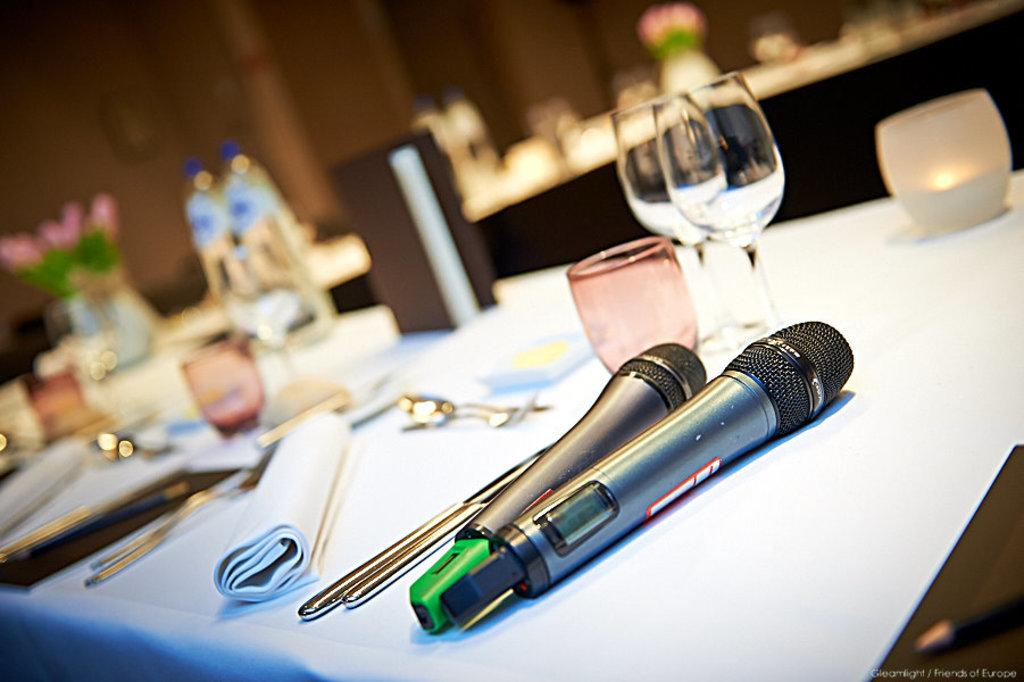What is located in the foreground of the image? In the foreground of the image, there are mice, glasses, spoons, tissue, and a candle. What objects can be seen in the same area as the mice? The glasses, spoons, tissue, and candle are all located in the same area as the mice in the foreground of the image. Can you describe the background of the image? The background of the image is blurred. What language is spoken by the mice in the image? There is no indication in the image that the mice are speaking any language. Is there a clock visible in the image? There is no mention of a clock in the provided facts, so it cannot be determined if one is present in the image. 